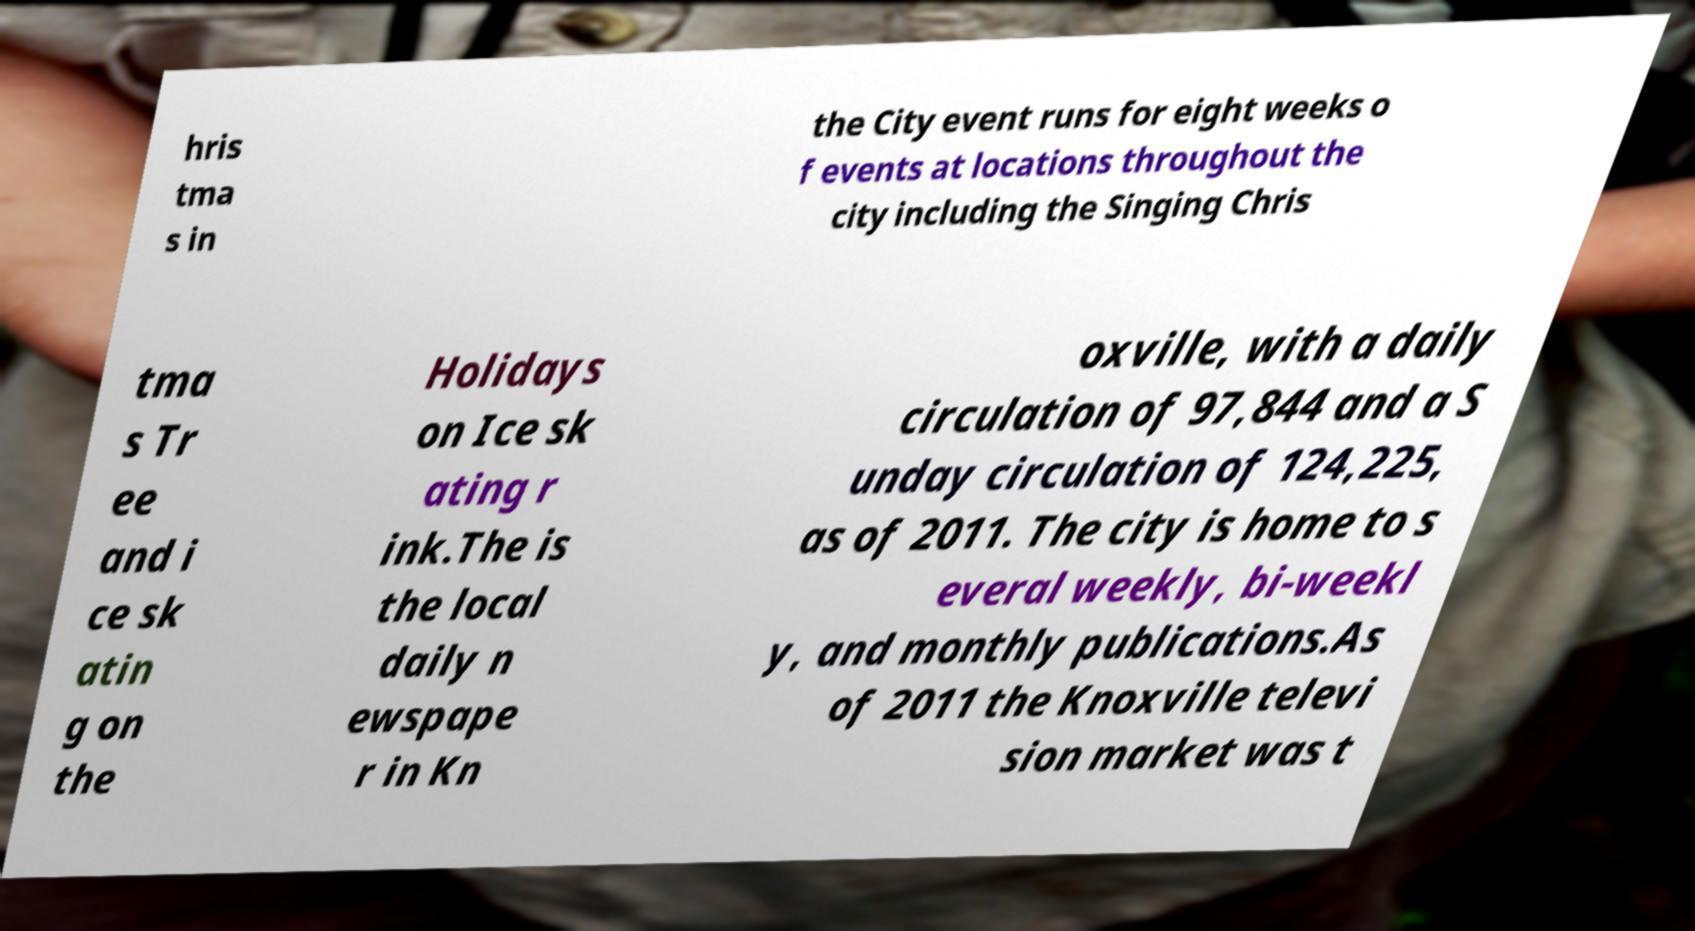I need the written content from this picture converted into text. Can you do that? hris tma s in the City event runs for eight weeks o f events at locations throughout the city including the Singing Chris tma s Tr ee and i ce sk atin g on the Holidays on Ice sk ating r ink.The is the local daily n ewspape r in Kn oxville, with a daily circulation of 97,844 and a S unday circulation of 124,225, as of 2011. The city is home to s everal weekly, bi-weekl y, and monthly publications.As of 2011 the Knoxville televi sion market was t 